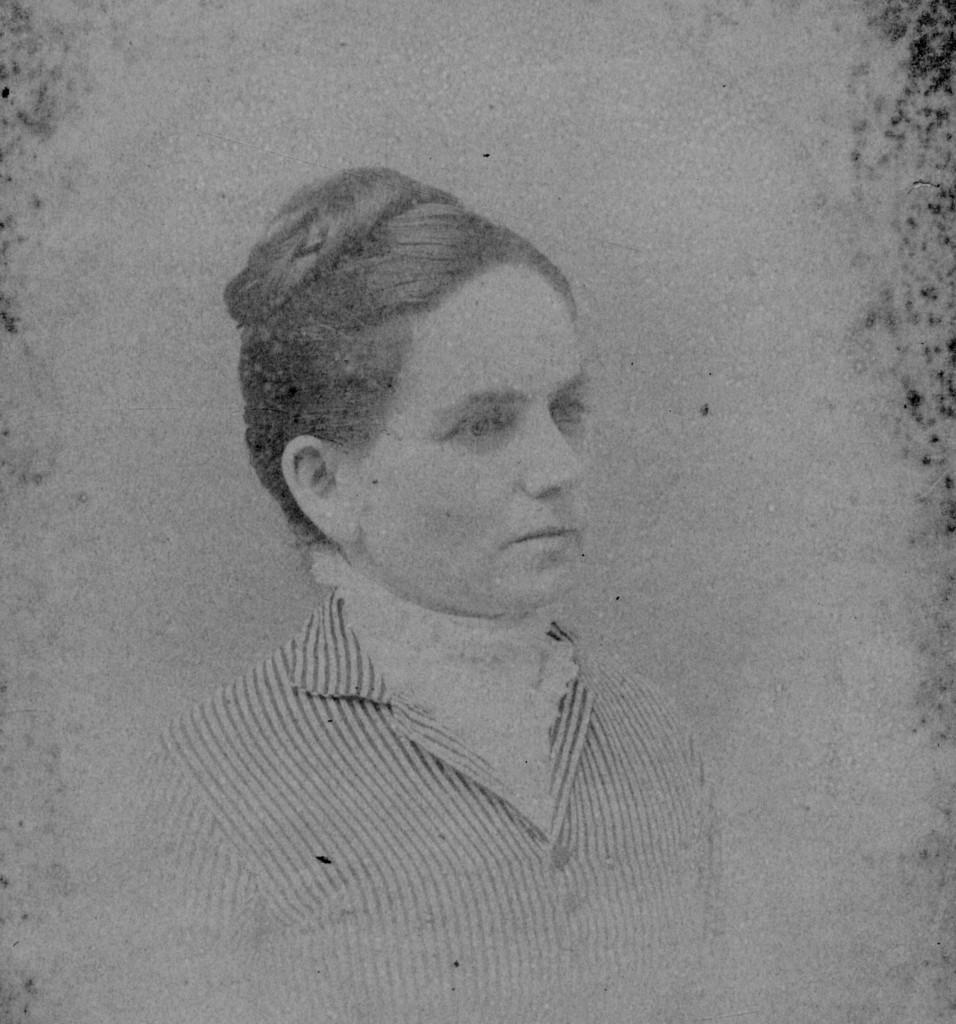Can you describe this image briefly? This is an edited image. There is a picture of a woman. 